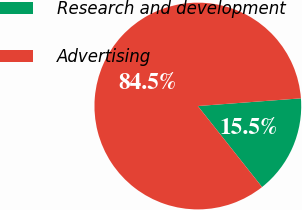Convert chart. <chart><loc_0><loc_0><loc_500><loc_500><pie_chart><fcel>Research and development<fcel>Advertising<nl><fcel>15.52%<fcel>84.48%<nl></chart> 